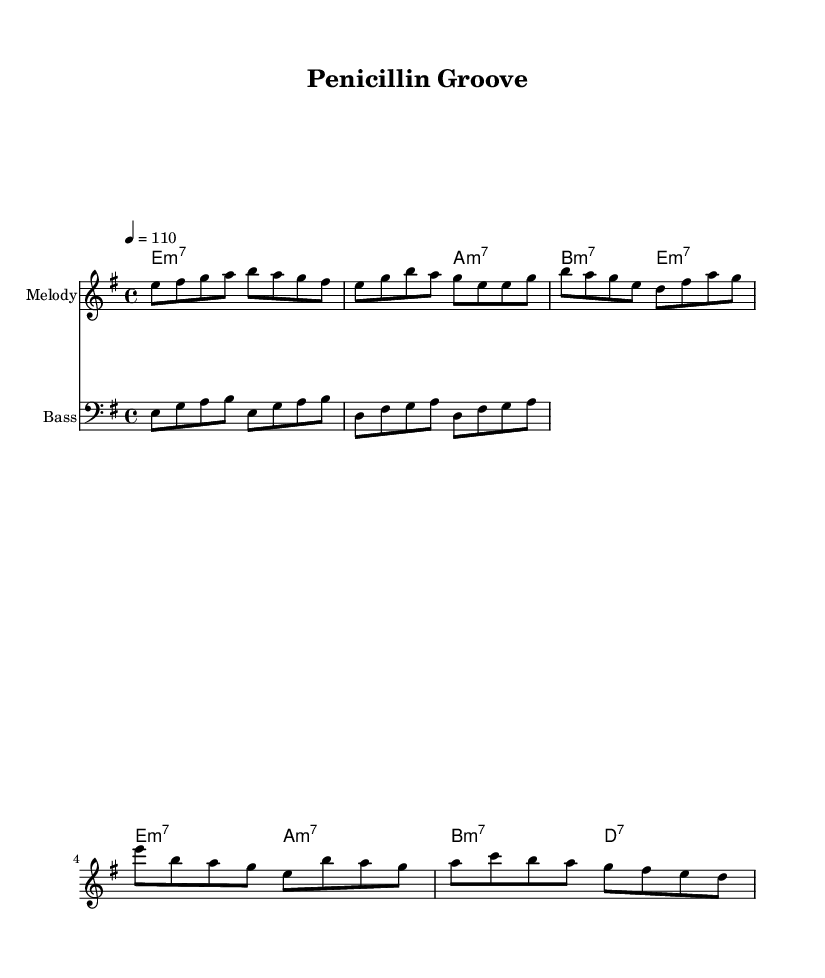What is the key signature of this music? The key signature at the beginning of the sheet music shows one sharp, indicating that the music is in E minor.
Answer: E minor What is the time signature of this music? The time signature displayed in the music is 4/4, which means there are four beats in a measure and a quarter note receives one beat.
Answer: 4/4 What is the tempo marking for this piece? The tempo marking indicated at the top of the score is “4 = 110,” which means there are 110 beats per minute, indicating a moderately fast pace.
Answer: 110 Which chord is played during the intro? The first chord shown in the harmonies section is E minor seventh (e:m7), which sets the mood for the song's introduction.
Answer: E minor seventh How many measures are in the chorus? By counting the bars in the melody section corresponding to the chorus part, there are a total of four measures present.
Answer: 4 What musical style does this sheet music represent? The use of syncopated rhythms, a strong bass line, and funky chord progressions throughout the piece aligns it with the Funk genre, which is known for its groove and danceability.
Answer: Funk What is the bass note of the first measure? In the bass line, the first note of the measure corresponds to an E note, which is the foundation of the groove for this section.
Answer: E 